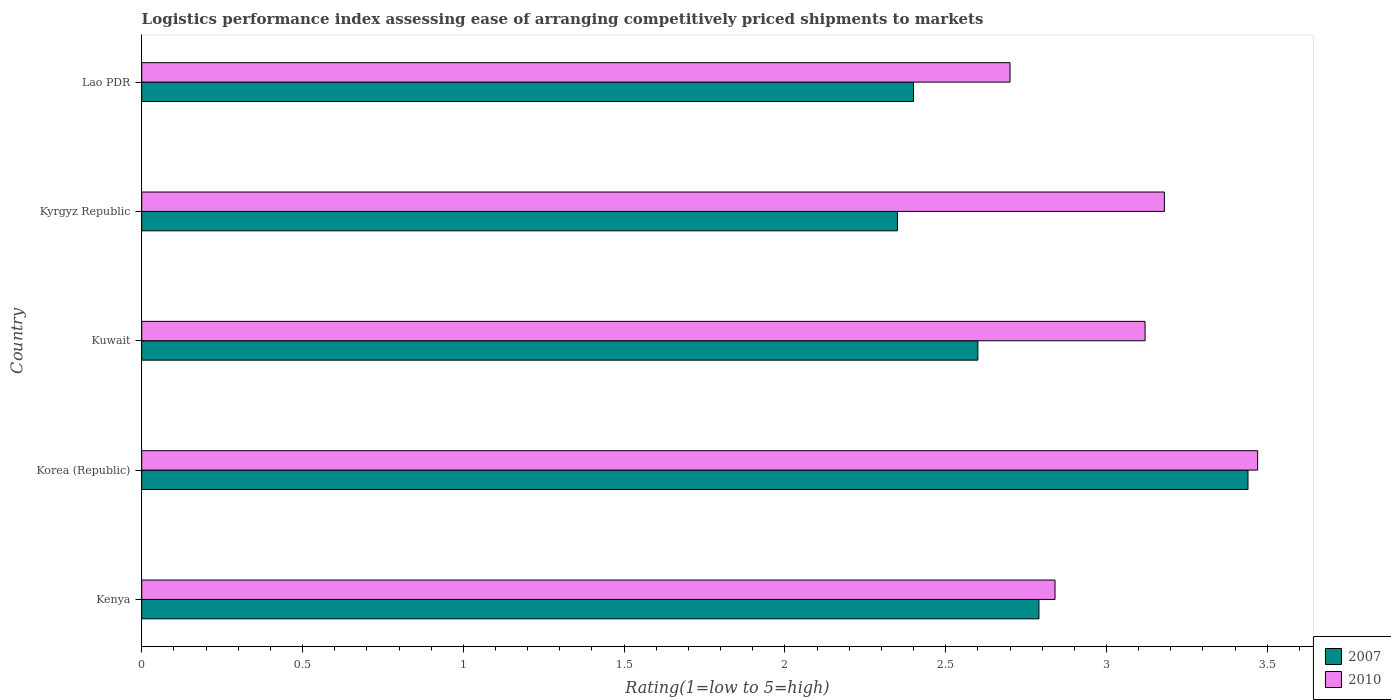How many groups of bars are there?
Offer a terse response. 5. What is the label of the 3rd group of bars from the top?
Keep it short and to the point. Kuwait. In how many cases, is the number of bars for a given country not equal to the number of legend labels?
Make the answer very short. 0. What is the Logistic performance index in 2010 in Kenya?
Your answer should be compact. 2.84. Across all countries, what is the maximum Logistic performance index in 2010?
Provide a short and direct response. 3.47. Across all countries, what is the minimum Logistic performance index in 2007?
Offer a very short reply. 2.35. In which country was the Logistic performance index in 2010 minimum?
Your answer should be compact. Lao PDR. What is the total Logistic performance index in 2007 in the graph?
Your answer should be compact. 13.58. What is the difference between the Logistic performance index in 2010 in Kenya and that in Korea (Republic)?
Offer a terse response. -0.63. What is the difference between the Logistic performance index in 2010 in Kyrgyz Republic and the Logistic performance index in 2007 in Kenya?
Offer a very short reply. 0.39. What is the average Logistic performance index in 2007 per country?
Your response must be concise. 2.72. What is the difference between the Logistic performance index in 2007 and Logistic performance index in 2010 in Korea (Republic)?
Offer a terse response. -0.03. What is the ratio of the Logistic performance index in 2007 in Kuwait to that in Lao PDR?
Keep it short and to the point. 1.08. Is the difference between the Logistic performance index in 2007 in Kenya and Lao PDR greater than the difference between the Logistic performance index in 2010 in Kenya and Lao PDR?
Ensure brevity in your answer.  Yes. What is the difference between the highest and the second highest Logistic performance index in 2010?
Your response must be concise. 0.29. What is the difference between the highest and the lowest Logistic performance index in 2010?
Your answer should be very brief. 0.77. What does the 2nd bar from the bottom in Kuwait represents?
Your answer should be very brief. 2010. How many bars are there?
Make the answer very short. 10. How many countries are there in the graph?
Provide a short and direct response. 5. Does the graph contain any zero values?
Your response must be concise. No. How many legend labels are there?
Make the answer very short. 2. What is the title of the graph?
Ensure brevity in your answer.  Logistics performance index assessing ease of arranging competitively priced shipments to markets. Does "1966" appear as one of the legend labels in the graph?
Provide a short and direct response. No. What is the label or title of the X-axis?
Your response must be concise. Rating(1=low to 5=high). What is the Rating(1=low to 5=high) of 2007 in Kenya?
Your answer should be compact. 2.79. What is the Rating(1=low to 5=high) in 2010 in Kenya?
Your answer should be very brief. 2.84. What is the Rating(1=low to 5=high) of 2007 in Korea (Republic)?
Offer a terse response. 3.44. What is the Rating(1=low to 5=high) of 2010 in Korea (Republic)?
Your answer should be compact. 3.47. What is the Rating(1=low to 5=high) in 2007 in Kuwait?
Your answer should be very brief. 2.6. What is the Rating(1=low to 5=high) of 2010 in Kuwait?
Your response must be concise. 3.12. What is the Rating(1=low to 5=high) in 2007 in Kyrgyz Republic?
Give a very brief answer. 2.35. What is the Rating(1=low to 5=high) in 2010 in Kyrgyz Republic?
Provide a succinct answer. 3.18. Across all countries, what is the maximum Rating(1=low to 5=high) in 2007?
Your answer should be very brief. 3.44. Across all countries, what is the maximum Rating(1=low to 5=high) of 2010?
Offer a very short reply. 3.47. Across all countries, what is the minimum Rating(1=low to 5=high) of 2007?
Provide a succinct answer. 2.35. Across all countries, what is the minimum Rating(1=low to 5=high) of 2010?
Give a very brief answer. 2.7. What is the total Rating(1=low to 5=high) in 2007 in the graph?
Keep it short and to the point. 13.58. What is the total Rating(1=low to 5=high) of 2010 in the graph?
Provide a succinct answer. 15.31. What is the difference between the Rating(1=low to 5=high) in 2007 in Kenya and that in Korea (Republic)?
Your answer should be very brief. -0.65. What is the difference between the Rating(1=low to 5=high) in 2010 in Kenya and that in Korea (Republic)?
Provide a short and direct response. -0.63. What is the difference between the Rating(1=low to 5=high) in 2007 in Kenya and that in Kuwait?
Make the answer very short. 0.19. What is the difference between the Rating(1=low to 5=high) in 2010 in Kenya and that in Kuwait?
Give a very brief answer. -0.28. What is the difference between the Rating(1=low to 5=high) of 2007 in Kenya and that in Kyrgyz Republic?
Keep it short and to the point. 0.44. What is the difference between the Rating(1=low to 5=high) of 2010 in Kenya and that in Kyrgyz Republic?
Give a very brief answer. -0.34. What is the difference between the Rating(1=low to 5=high) of 2007 in Kenya and that in Lao PDR?
Give a very brief answer. 0.39. What is the difference between the Rating(1=low to 5=high) in 2010 in Kenya and that in Lao PDR?
Provide a succinct answer. 0.14. What is the difference between the Rating(1=low to 5=high) of 2007 in Korea (Republic) and that in Kuwait?
Provide a short and direct response. 0.84. What is the difference between the Rating(1=low to 5=high) in 2007 in Korea (Republic) and that in Kyrgyz Republic?
Ensure brevity in your answer.  1.09. What is the difference between the Rating(1=low to 5=high) in 2010 in Korea (Republic) and that in Kyrgyz Republic?
Make the answer very short. 0.29. What is the difference between the Rating(1=low to 5=high) of 2010 in Korea (Republic) and that in Lao PDR?
Keep it short and to the point. 0.77. What is the difference between the Rating(1=low to 5=high) of 2010 in Kuwait and that in Kyrgyz Republic?
Your answer should be compact. -0.06. What is the difference between the Rating(1=low to 5=high) of 2010 in Kuwait and that in Lao PDR?
Make the answer very short. 0.42. What is the difference between the Rating(1=low to 5=high) in 2010 in Kyrgyz Republic and that in Lao PDR?
Your response must be concise. 0.48. What is the difference between the Rating(1=low to 5=high) in 2007 in Kenya and the Rating(1=low to 5=high) in 2010 in Korea (Republic)?
Keep it short and to the point. -0.68. What is the difference between the Rating(1=low to 5=high) of 2007 in Kenya and the Rating(1=low to 5=high) of 2010 in Kuwait?
Provide a short and direct response. -0.33. What is the difference between the Rating(1=low to 5=high) in 2007 in Kenya and the Rating(1=low to 5=high) in 2010 in Kyrgyz Republic?
Provide a succinct answer. -0.39. What is the difference between the Rating(1=low to 5=high) in 2007 in Kenya and the Rating(1=low to 5=high) in 2010 in Lao PDR?
Provide a short and direct response. 0.09. What is the difference between the Rating(1=low to 5=high) in 2007 in Korea (Republic) and the Rating(1=low to 5=high) in 2010 in Kuwait?
Your response must be concise. 0.32. What is the difference between the Rating(1=low to 5=high) of 2007 in Korea (Republic) and the Rating(1=low to 5=high) of 2010 in Kyrgyz Republic?
Offer a terse response. 0.26. What is the difference between the Rating(1=low to 5=high) in 2007 in Korea (Republic) and the Rating(1=low to 5=high) in 2010 in Lao PDR?
Your response must be concise. 0.74. What is the difference between the Rating(1=low to 5=high) in 2007 in Kuwait and the Rating(1=low to 5=high) in 2010 in Kyrgyz Republic?
Provide a short and direct response. -0.58. What is the difference between the Rating(1=low to 5=high) in 2007 in Kyrgyz Republic and the Rating(1=low to 5=high) in 2010 in Lao PDR?
Make the answer very short. -0.35. What is the average Rating(1=low to 5=high) in 2007 per country?
Your answer should be compact. 2.72. What is the average Rating(1=low to 5=high) in 2010 per country?
Ensure brevity in your answer.  3.06. What is the difference between the Rating(1=low to 5=high) in 2007 and Rating(1=low to 5=high) in 2010 in Korea (Republic)?
Ensure brevity in your answer.  -0.03. What is the difference between the Rating(1=low to 5=high) in 2007 and Rating(1=low to 5=high) in 2010 in Kuwait?
Provide a short and direct response. -0.52. What is the difference between the Rating(1=low to 5=high) of 2007 and Rating(1=low to 5=high) of 2010 in Kyrgyz Republic?
Provide a short and direct response. -0.83. What is the difference between the Rating(1=low to 5=high) in 2007 and Rating(1=low to 5=high) in 2010 in Lao PDR?
Your answer should be very brief. -0.3. What is the ratio of the Rating(1=low to 5=high) in 2007 in Kenya to that in Korea (Republic)?
Your answer should be compact. 0.81. What is the ratio of the Rating(1=low to 5=high) of 2010 in Kenya to that in Korea (Republic)?
Your answer should be very brief. 0.82. What is the ratio of the Rating(1=low to 5=high) in 2007 in Kenya to that in Kuwait?
Keep it short and to the point. 1.07. What is the ratio of the Rating(1=low to 5=high) in 2010 in Kenya to that in Kuwait?
Give a very brief answer. 0.91. What is the ratio of the Rating(1=low to 5=high) in 2007 in Kenya to that in Kyrgyz Republic?
Give a very brief answer. 1.19. What is the ratio of the Rating(1=low to 5=high) of 2010 in Kenya to that in Kyrgyz Republic?
Your response must be concise. 0.89. What is the ratio of the Rating(1=low to 5=high) in 2007 in Kenya to that in Lao PDR?
Provide a short and direct response. 1.16. What is the ratio of the Rating(1=low to 5=high) in 2010 in Kenya to that in Lao PDR?
Offer a very short reply. 1.05. What is the ratio of the Rating(1=low to 5=high) in 2007 in Korea (Republic) to that in Kuwait?
Ensure brevity in your answer.  1.32. What is the ratio of the Rating(1=low to 5=high) in 2010 in Korea (Republic) to that in Kuwait?
Your response must be concise. 1.11. What is the ratio of the Rating(1=low to 5=high) of 2007 in Korea (Republic) to that in Kyrgyz Republic?
Your response must be concise. 1.46. What is the ratio of the Rating(1=low to 5=high) of 2010 in Korea (Republic) to that in Kyrgyz Republic?
Offer a terse response. 1.09. What is the ratio of the Rating(1=low to 5=high) in 2007 in Korea (Republic) to that in Lao PDR?
Provide a short and direct response. 1.43. What is the ratio of the Rating(1=low to 5=high) of 2010 in Korea (Republic) to that in Lao PDR?
Your answer should be compact. 1.29. What is the ratio of the Rating(1=low to 5=high) of 2007 in Kuwait to that in Kyrgyz Republic?
Keep it short and to the point. 1.11. What is the ratio of the Rating(1=low to 5=high) of 2010 in Kuwait to that in Kyrgyz Republic?
Make the answer very short. 0.98. What is the ratio of the Rating(1=low to 5=high) in 2010 in Kuwait to that in Lao PDR?
Your response must be concise. 1.16. What is the ratio of the Rating(1=low to 5=high) of 2007 in Kyrgyz Republic to that in Lao PDR?
Your answer should be very brief. 0.98. What is the ratio of the Rating(1=low to 5=high) of 2010 in Kyrgyz Republic to that in Lao PDR?
Provide a short and direct response. 1.18. What is the difference between the highest and the second highest Rating(1=low to 5=high) of 2007?
Give a very brief answer. 0.65. What is the difference between the highest and the second highest Rating(1=low to 5=high) of 2010?
Ensure brevity in your answer.  0.29. What is the difference between the highest and the lowest Rating(1=low to 5=high) of 2007?
Offer a terse response. 1.09. What is the difference between the highest and the lowest Rating(1=low to 5=high) of 2010?
Provide a succinct answer. 0.77. 